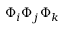<formula> <loc_0><loc_0><loc_500><loc_500>\Phi _ { i } \Phi _ { j } \Phi _ { k }</formula> 